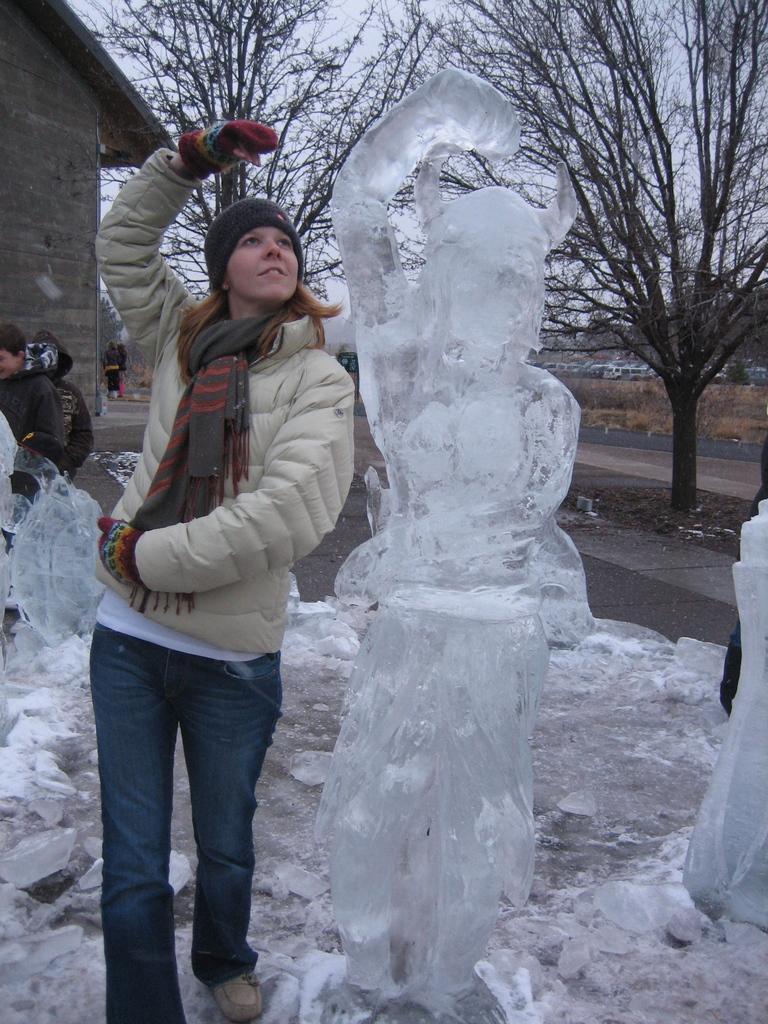How would you summarize this image in a sentence or two? In this picture there are people and we can see ice sculptures. In the background of the image we can see wall, trees, grass and sky. 